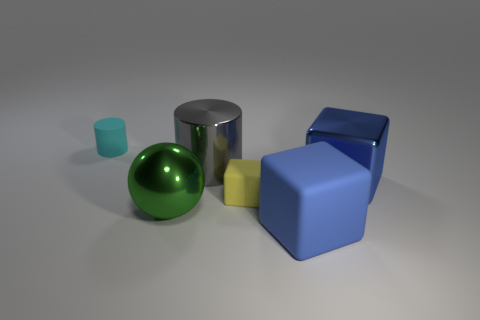Is the number of large blue shiny objects in front of the large rubber thing less than the number of big gray metal things in front of the metallic cylinder?
Your response must be concise. No. What is the material of the green thing that is the same size as the gray shiny thing?
Your answer should be compact. Metal. What number of purple things are cubes or spheres?
Offer a very short reply. 0. What color is the thing that is in front of the cyan matte cylinder and left of the big gray shiny cylinder?
Your response must be concise. Green. Does the cylinder in front of the tiny cylinder have the same material as the blue thing in front of the blue metallic thing?
Make the answer very short. No. Are there more big blue rubber blocks to the left of the big green thing than metallic spheres behind the large gray metallic cylinder?
Your response must be concise. No. What is the shape of the matte object that is the same size as the metallic block?
Ensure brevity in your answer.  Cube. What number of things are big green shiny things or rubber things right of the cyan cylinder?
Your response must be concise. 3. Is the big sphere the same color as the big matte cube?
Make the answer very short. No. There is a big metal sphere; how many yellow cubes are in front of it?
Keep it short and to the point. 0. 